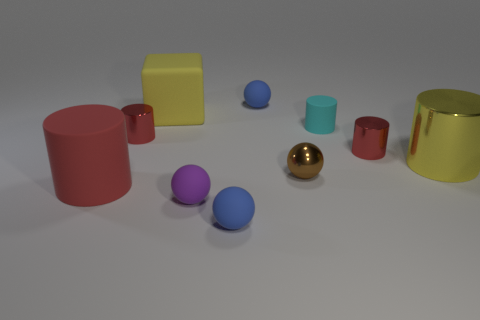What is the color of the small matte object that is the same shape as the big red thing?
Ensure brevity in your answer.  Cyan. Do the large block and the big metallic object have the same color?
Provide a succinct answer. Yes. What is the color of the big cube that is made of the same material as the tiny purple object?
Your response must be concise. Yellow. What is the color of the matte cylinder that is the same size as the brown sphere?
Your answer should be very brief. Cyan. There is a red metallic cylinder that is to the right of the matte cylinder behind the rubber cylinder left of the tiny brown shiny ball; what is its size?
Your response must be concise. Small. How many other things are there of the same size as the yellow cube?
Your answer should be very brief. 2. What is the size of the sphere that is behind the large yellow block?
Your answer should be compact. Small. Is there anything else of the same color as the metallic ball?
Make the answer very short. No. Does the small blue ball that is behind the large red matte object have the same material as the cyan object?
Your answer should be very brief. Yes. How many cylinders are both left of the large yellow cylinder and right of the small purple thing?
Offer a very short reply. 2. 